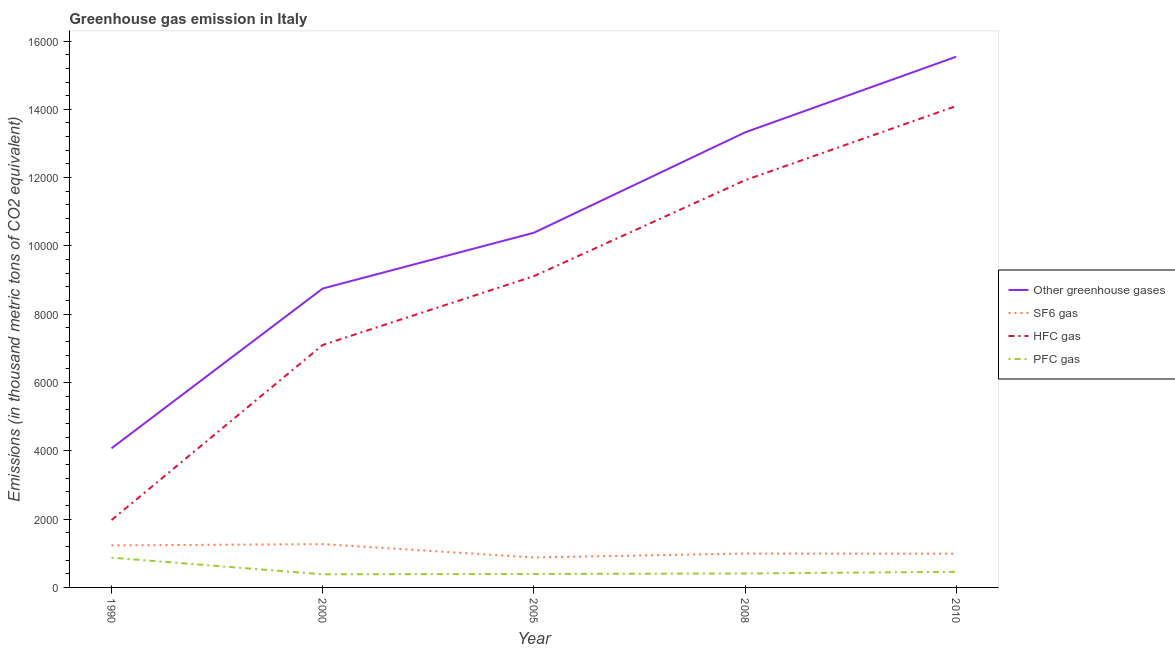How many different coloured lines are there?
Keep it short and to the point. 4. Does the line corresponding to emission of sf6 gas intersect with the line corresponding to emission of pfc gas?
Provide a succinct answer. No. Is the number of lines equal to the number of legend labels?
Keep it short and to the point. Yes. What is the emission of hfc gas in 2000?
Make the answer very short. 7099.5. Across all years, what is the maximum emission of hfc gas?
Your answer should be very brief. 1.41e+04. Across all years, what is the minimum emission of hfc gas?
Your answer should be very brief. 1972.2. In which year was the emission of hfc gas maximum?
Your response must be concise. 2010. In which year was the emission of pfc gas minimum?
Keep it short and to the point. 2000. What is the total emission of pfc gas in the graph?
Offer a very short reply. 2515.4. What is the difference between the emission of hfc gas in 2000 and that in 2005?
Your answer should be very brief. -2015. What is the difference between the emission of hfc gas in 2000 and the emission of sf6 gas in 2008?
Provide a succinct answer. 6107.4. What is the average emission of sf6 gas per year?
Your answer should be very brief. 1071.12. In the year 2008, what is the difference between the emission of pfc gas and emission of hfc gas?
Make the answer very short. -1.15e+04. What is the ratio of the emission of sf6 gas in 2000 to that in 2010?
Ensure brevity in your answer.  1.29. Is the emission of greenhouse gases in 1990 less than that in 2008?
Provide a succinct answer. Yes. Is the difference between the emission of greenhouse gases in 2000 and 2010 greater than the difference between the emission of pfc gas in 2000 and 2010?
Provide a short and direct response. No. What is the difference between the highest and the second highest emission of pfc gas?
Offer a very short reply. 414. What is the difference between the highest and the lowest emission of greenhouse gases?
Your response must be concise. 1.15e+04. In how many years, is the emission of sf6 gas greater than the average emission of sf6 gas taken over all years?
Ensure brevity in your answer.  2. Is the sum of the emission of hfc gas in 1990 and 2000 greater than the maximum emission of sf6 gas across all years?
Your answer should be very brief. Yes. Does the emission of hfc gas monotonically increase over the years?
Offer a terse response. Yes. Is the emission of sf6 gas strictly greater than the emission of pfc gas over the years?
Your answer should be very brief. Yes. Is the emission of greenhouse gases strictly less than the emission of hfc gas over the years?
Keep it short and to the point. No. What is the difference between two consecutive major ticks on the Y-axis?
Keep it short and to the point. 2000. Are the values on the major ticks of Y-axis written in scientific E-notation?
Keep it short and to the point. No. Does the graph contain any zero values?
Provide a short and direct response. No. What is the title of the graph?
Provide a succinct answer. Greenhouse gas emission in Italy. What is the label or title of the X-axis?
Ensure brevity in your answer.  Year. What is the label or title of the Y-axis?
Offer a very short reply. Emissions (in thousand metric tons of CO2 equivalent). What is the Emissions (in thousand metric tons of CO2 equivalent) in Other greenhouse gases in 1990?
Provide a short and direct response. 4074. What is the Emissions (in thousand metric tons of CO2 equivalent) in SF6 gas in 1990?
Keep it short and to the point. 1230.8. What is the Emissions (in thousand metric tons of CO2 equivalent) in HFC gas in 1990?
Keep it short and to the point. 1972.2. What is the Emissions (in thousand metric tons of CO2 equivalent) of PFC gas in 1990?
Offer a terse response. 871. What is the Emissions (in thousand metric tons of CO2 equivalent) in Other greenhouse gases in 2000?
Make the answer very short. 8752.3. What is the Emissions (in thousand metric tons of CO2 equivalent) of SF6 gas in 2000?
Your answer should be compact. 1268.5. What is the Emissions (in thousand metric tons of CO2 equivalent) of HFC gas in 2000?
Ensure brevity in your answer.  7099.5. What is the Emissions (in thousand metric tons of CO2 equivalent) in PFC gas in 2000?
Provide a succinct answer. 384.3. What is the Emissions (in thousand metric tons of CO2 equivalent) of Other greenhouse gases in 2005?
Give a very brief answer. 1.04e+04. What is the Emissions (in thousand metric tons of CO2 equivalent) in SF6 gas in 2005?
Your response must be concise. 877.2. What is the Emissions (in thousand metric tons of CO2 equivalent) of HFC gas in 2005?
Ensure brevity in your answer.  9114.5. What is the Emissions (in thousand metric tons of CO2 equivalent) in PFC gas in 2005?
Your answer should be compact. 394.3. What is the Emissions (in thousand metric tons of CO2 equivalent) in Other greenhouse gases in 2008?
Offer a very short reply. 1.33e+04. What is the Emissions (in thousand metric tons of CO2 equivalent) of SF6 gas in 2008?
Your response must be concise. 992.1. What is the Emissions (in thousand metric tons of CO2 equivalent) of HFC gas in 2008?
Your answer should be very brief. 1.19e+04. What is the Emissions (in thousand metric tons of CO2 equivalent) in PFC gas in 2008?
Give a very brief answer. 408.8. What is the Emissions (in thousand metric tons of CO2 equivalent) of Other greenhouse gases in 2010?
Your response must be concise. 1.55e+04. What is the Emissions (in thousand metric tons of CO2 equivalent) of SF6 gas in 2010?
Your answer should be compact. 987. What is the Emissions (in thousand metric tons of CO2 equivalent) in HFC gas in 2010?
Your answer should be very brief. 1.41e+04. What is the Emissions (in thousand metric tons of CO2 equivalent) of PFC gas in 2010?
Offer a terse response. 457. Across all years, what is the maximum Emissions (in thousand metric tons of CO2 equivalent) in Other greenhouse gases?
Offer a terse response. 1.55e+04. Across all years, what is the maximum Emissions (in thousand metric tons of CO2 equivalent) in SF6 gas?
Your response must be concise. 1268.5. Across all years, what is the maximum Emissions (in thousand metric tons of CO2 equivalent) in HFC gas?
Offer a terse response. 1.41e+04. Across all years, what is the maximum Emissions (in thousand metric tons of CO2 equivalent) of PFC gas?
Your answer should be compact. 871. Across all years, what is the minimum Emissions (in thousand metric tons of CO2 equivalent) in Other greenhouse gases?
Provide a succinct answer. 4074. Across all years, what is the minimum Emissions (in thousand metric tons of CO2 equivalent) in SF6 gas?
Give a very brief answer. 877.2. Across all years, what is the minimum Emissions (in thousand metric tons of CO2 equivalent) in HFC gas?
Your answer should be very brief. 1972.2. Across all years, what is the minimum Emissions (in thousand metric tons of CO2 equivalent) of PFC gas?
Provide a short and direct response. 384.3. What is the total Emissions (in thousand metric tons of CO2 equivalent) in Other greenhouse gases in the graph?
Offer a terse response. 5.21e+04. What is the total Emissions (in thousand metric tons of CO2 equivalent) in SF6 gas in the graph?
Your answer should be compact. 5355.6. What is the total Emissions (in thousand metric tons of CO2 equivalent) of HFC gas in the graph?
Ensure brevity in your answer.  4.42e+04. What is the total Emissions (in thousand metric tons of CO2 equivalent) in PFC gas in the graph?
Your response must be concise. 2515.4. What is the difference between the Emissions (in thousand metric tons of CO2 equivalent) of Other greenhouse gases in 1990 and that in 2000?
Your response must be concise. -4678.3. What is the difference between the Emissions (in thousand metric tons of CO2 equivalent) in SF6 gas in 1990 and that in 2000?
Provide a short and direct response. -37.7. What is the difference between the Emissions (in thousand metric tons of CO2 equivalent) in HFC gas in 1990 and that in 2000?
Ensure brevity in your answer.  -5127.3. What is the difference between the Emissions (in thousand metric tons of CO2 equivalent) of PFC gas in 1990 and that in 2000?
Provide a short and direct response. 486.7. What is the difference between the Emissions (in thousand metric tons of CO2 equivalent) of Other greenhouse gases in 1990 and that in 2005?
Provide a short and direct response. -6312. What is the difference between the Emissions (in thousand metric tons of CO2 equivalent) in SF6 gas in 1990 and that in 2005?
Your answer should be compact. 353.6. What is the difference between the Emissions (in thousand metric tons of CO2 equivalent) of HFC gas in 1990 and that in 2005?
Keep it short and to the point. -7142.3. What is the difference between the Emissions (in thousand metric tons of CO2 equivalent) of PFC gas in 1990 and that in 2005?
Make the answer very short. 476.7. What is the difference between the Emissions (in thousand metric tons of CO2 equivalent) in Other greenhouse gases in 1990 and that in 2008?
Your answer should be compact. -9251.4. What is the difference between the Emissions (in thousand metric tons of CO2 equivalent) in SF6 gas in 1990 and that in 2008?
Keep it short and to the point. 238.7. What is the difference between the Emissions (in thousand metric tons of CO2 equivalent) of HFC gas in 1990 and that in 2008?
Your answer should be compact. -9952.3. What is the difference between the Emissions (in thousand metric tons of CO2 equivalent) in PFC gas in 1990 and that in 2008?
Your answer should be very brief. 462.2. What is the difference between the Emissions (in thousand metric tons of CO2 equivalent) in Other greenhouse gases in 1990 and that in 2010?
Give a very brief answer. -1.15e+04. What is the difference between the Emissions (in thousand metric tons of CO2 equivalent) in SF6 gas in 1990 and that in 2010?
Your answer should be very brief. 243.8. What is the difference between the Emissions (in thousand metric tons of CO2 equivalent) of HFC gas in 1990 and that in 2010?
Keep it short and to the point. -1.21e+04. What is the difference between the Emissions (in thousand metric tons of CO2 equivalent) in PFC gas in 1990 and that in 2010?
Ensure brevity in your answer.  414. What is the difference between the Emissions (in thousand metric tons of CO2 equivalent) of Other greenhouse gases in 2000 and that in 2005?
Keep it short and to the point. -1633.7. What is the difference between the Emissions (in thousand metric tons of CO2 equivalent) in SF6 gas in 2000 and that in 2005?
Your answer should be compact. 391.3. What is the difference between the Emissions (in thousand metric tons of CO2 equivalent) in HFC gas in 2000 and that in 2005?
Provide a short and direct response. -2015. What is the difference between the Emissions (in thousand metric tons of CO2 equivalent) in Other greenhouse gases in 2000 and that in 2008?
Your answer should be compact. -4573.1. What is the difference between the Emissions (in thousand metric tons of CO2 equivalent) of SF6 gas in 2000 and that in 2008?
Provide a short and direct response. 276.4. What is the difference between the Emissions (in thousand metric tons of CO2 equivalent) of HFC gas in 2000 and that in 2008?
Offer a very short reply. -4825. What is the difference between the Emissions (in thousand metric tons of CO2 equivalent) of PFC gas in 2000 and that in 2008?
Ensure brevity in your answer.  -24.5. What is the difference between the Emissions (in thousand metric tons of CO2 equivalent) of Other greenhouse gases in 2000 and that in 2010?
Offer a terse response. -6788.7. What is the difference between the Emissions (in thousand metric tons of CO2 equivalent) of SF6 gas in 2000 and that in 2010?
Your response must be concise. 281.5. What is the difference between the Emissions (in thousand metric tons of CO2 equivalent) of HFC gas in 2000 and that in 2010?
Provide a short and direct response. -6997.5. What is the difference between the Emissions (in thousand metric tons of CO2 equivalent) in PFC gas in 2000 and that in 2010?
Provide a short and direct response. -72.7. What is the difference between the Emissions (in thousand metric tons of CO2 equivalent) in Other greenhouse gases in 2005 and that in 2008?
Offer a terse response. -2939.4. What is the difference between the Emissions (in thousand metric tons of CO2 equivalent) of SF6 gas in 2005 and that in 2008?
Your response must be concise. -114.9. What is the difference between the Emissions (in thousand metric tons of CO2 equivalent) in HFC gas in 2005 and that in 2008?
Keep it short and to the point. -2810. What is the difference between the Emissions (in thousand metric tons of CO2 equivalent) in Other greenhouse gases in 2005 and that in 2010?
Keep it short and to the point. -5155. What is the difference between the Emissions (in thousand metric tons of CO2 equivalent) in SF6 gas in 2005 and that in 2010?
Give a very brief answer. -109.8. What is the difference between the Emissions (in thousand metric tons of CO2 equivalent) in HFC gas in 2005 and that in 2010?
Your answer should be compact. -4982.5. What is the difference between the Emissions (in thousand metric tons of CO2 equivalent) of PFC gas in 2005 and that in 2010?
Ensure brevity in your answer.  -62.7. What is the difference between the Emissions (in thousand metric tons of CO2 equivalent) of Other greenhouse gases in 2008 and that in 2010?
Make the answer very short. -2215.6. What is the difference between the Emissions (in thousand metric tons of CO2 equivalent) in HFC gas in 2008 and that in 2010?
Provide a short and direct response. -2172.5. What is the difference between the Emissions (in thousand metric tons of CO2 equivalent) of PFC gas in 2008 and that in 2010?
Your answer should be compact. -48.2. What is the difference between the Emissions (in thousand metric tons of CO2 equivalent) in Other greenhouse gases in 1990 and the Emissions (in thousand metric tons of CO2 equivalent) in SF6 gas in 2000?
Offer a very short reply. 2805.5. What is the difference between the Emissions (in thousand metric tons of CO2 equivalent) of Other greenhouse gases in 1990 and the Emissions (in thousand metric tons of CO2 equivalent) of HFC gas in 2000?
Keep it short and to the point. -3025.5. What is the difference between the Emissions (in thousand metric tons of CO2 equivalent) in Other greenhouse gases in 1990 and the Emissions (in thousand metric tons of CO2 equivalent) in PFC gas in 2000?
Offer a very short reply. 3689.7. What is the difference between the Emissions (in thousand metric tons of CO2 equivalent) of SF6 gas in 1990 and the Emissions (in thousand metric tons of CO2 equivalent) of HFC gas in 2000?
Make the answer very short. -5868.7. What is the difference between the Emissions (in thousand metric tons of CO2 equivalent) in SF6 gas in 1990 and the Emissions (in thousand metric tons of CO2 equivalent) in PFC gas in 2000?
Your answer should be compact. 846.5. What is the difference between the Emissions (in thousand metric tons of CO2 equivalent) in HFC gas in 1990 and the Emissions (in thousand metric tons of CO2 equivalent) in PFC gas in 2000?
Offer a terse response. 1587.9. What is the difference between the Emissions (in thousand metric tons of CO2 equivalent) in Other greenhouse gases in 1990 and the Emissions (in thousand metric tons of CO2 equivalent) in SF6 gas in 2005?
Give a very brief answer. 3196.8. What is the difference between the Emissions (in thousand metric tons of CO2 equivalent) in Other greenhouse gases in 1990 and the Emissions (in thousand metric tons of CO2 equivalent) in HFC gas in 2005?
Make the answer very short. -5040.5. What is the difference between the Emissions (in thousand metric tons of CO2 equivalent) of Other greenhouse gases in 1990 and the Emissions (in thousand metric tons of CO2 equivalent) of PFC gas in 2005?
Your answer should be compact. 3679.7. What is the difference between the Emissions (in thousand metric tons of CO2 equivalent) in SF6 gas in 1990 and the Emissions (in thousand metric tons of CO2 equivalent) in HFC gas in 2005?
Ensure brevity in your answer.  -7883.7. What is the difference between the Emissions (in thousand metric tons of CO2 equivalent) of SF6 gas in 1990 and the Emissions (in thousand metric tons of CO2 equivalent) of PFC gas in 2005?
Make the answer very short. 836.5. What is the difference between the Emissions (in thousand metric tons of CO2 equivalent) of HFC gas in 1990 and the Emissions (in thousand metric tons of CO2 equivalent) of PFC gas in 2005?
Your answer should be very brief. 1577.9. What is the difference between the Emissions (in thousand metric tons of CO2 equivalent) in Other greenhouse gases in 1990 and the Emissions (in thousand metric tons of CO2 equivalent) in SF6 gas in 2008?
Give a very brief answer. 3081.9. What is the difference between the Emissions (in thousand metric tons of CO2 equivalent) of Other greenhouse gases in 1990 and the Emissions (in thousand metric tons of CO2 equivalent) of HFC gas in 2008?
Keep it short and to the point. -7850.5. What is the difference between the Emissions (in thousand metric tons of CO2 equivalent) in Other greenhouse gases in 1990 and the Emissions (in thousand metric tons of CO2 equivalent) in PFC gas in 2008?
Your answer should be compact. 3665.2. What is the difference between the Emissions (in thousand metric tons of CO2 equivalent) of SF6 gas in 1990 and the Emissions (in thousand metric tons of CO2 equivalent) of HFC gas in 2008?
Your response must be concise. -1.07e+04. What is the difference between the Emissions (in thousand metric tons of CO2 equivalent) of SF6 gas in 1990 and the Emissions (in thousand metric tons of CO2 equivalent) of PFC gas in 2008?
Your answer should be very brief. 822. What is the difference between the Emissions (in thousand metric tons of CO2 equivalent) in HFC gas in 1990 and the Emissions (in thousand metric tons of CO2 equivalent) in PFC gas in 2008?
Provide a short and direct response. 1563.4. What is the difference between the Emissions (in thousand metric tons of CO2 equivalent) in Other greenhouse gases in 1990 and the Emissions (in thousand metric tons of CO2 equivalent) in SF6 gas in 2010?
Provide a short and direct response. 3087. What is the difference between the Emissions (in thousand metric tons of CO2 equivalent) in Other greenhouse gases in 1990 and the Emissions (in thousand metric tons of CO2 equivalent) in HFC gas in 2010?
Give a very brief answer. -1.00e+04. What is the difference between the Emissions (in thousand metric tons of CO2 equivalent) of Other greenhouse gases in 1990 and the Emissions (in thousand metric tons of CO2 equivalent) of PFC gas in 2010?
Your answer should be very brief. 3617. What is the difference between the Emissions (in thousand metric tons of CO2 equivalent) in SF6 gas in 1990 and the Emissions (in thousand metric tons of CO2 equivalent) in HFC gas in 2010?
Ensure brevity in your answer.  -1.29e+04. What is the difference between the Emissions (in thousand metric tons of CO2 equivalent) of SF6 gas in 1990 and the Emissions (in thousand metric tons of CO2 equivalent) of PFC gas in 2010?
Provide a short and direct response. 773.8. What is the difference between the Emissions (in thousand metric tons of CO2 equivalent) in HFC gas in 1990 and the Emissions (in thousand metric tons of CO2 equivalent) in PFC gas in 2010?
Keep it short and to the point. 1515.2. What is the difference between the Emissions (in thousand metric tons of CO2 equivalent) in Other greenhouse gases in 2000 and the Emissions (in thousand metric tons of CO2 equivalent) in SF6 gas in 2005?
Provide a short and direct response. 7875.1. What is the difference between the Emissions (in thousand metric tons of CO2 equivalent) of Other greenhouse gases in 2000 and the Emissions (in thousand metric tons of CO2 equivalent) of HFC gas in 2005?
Your response must be concise. -362.2. What is the difference between the Emissions (in thousand metric tons of CO2 equivalent) in Other greenhouse gases in 2000 and the Emissions (in thousand metric tons of CO2 equivalent) in PFC gas in 2005?
Keep it short and to the point. 8358. What is the difference between the Emissions (in thousand metric tons of CO2 equivalent) of SF6 gas in 2000 and the Emissions (in thousand metric tons of CO2 equivalent) of HFC gas in 2005?
Provide a short and direct response. -7846. What is the difference between the Emissions (in thousand metric tons of CO2 equivalent) of SF6 gas in 2000 and the Emissions (in thousand metric tons of CO2 equivalent) of PFC gas in 2005?
Your answer should be very brief. 874.2. What is the difference between the Emissions (in thousand metric tons of CO2 equivalent) in HFC gas in 2000 and the Emissions (in thousand metric tons of CO2 equivalent) in PFC gas in 2005?
Provide a short and direct response. 6705.2. What is the difference between the Emissions (in thousand metric tons of CO2 equivalent) in Other greenhouse gases in 2000 and the Emissions (in thousand metric tons of CO2 equivalent) in SF6 gas in 2008?
Your answer should be compact. 7760.2. What is the difference between the Emissions (in thousand metric tons of CO2 equivalent) in Other greenhouse gases in 2000 and the Emissions (in thousand metric tons of CO2 equivalent) in HFC gas in 2008?
Your answer should be very brief. -3172.2. What is the difference between the Emissions (in thousand metric tons of CO2 equivalent) of Other greenhouse gases in 2000 and the Emissions (in thousand metric tons of CO2 equivalent) of PFC gas in 2008?
Provide a succinct answer. 8343.5. What is the difference between the Emissions (in thousand metric tons of CO2 equivalent) in SF6 gas in 2000 and the Emissions (in thousand metric tons of CO2 equivalent) in HFC gas in 2008?
Make the answer very short. -1.07e+04. What is the difference between the Emissions (in thousand metric tons of CO2 equivalent) in SF6 gas in 2000 and the Emissions (in thousand metric tons of CO2 equivalent) in PFC gas in 2008?
Ensure brevity in your answer.  859.7. What is the difference between the Emissions (in thousand metric tons of CO2 equivalent) in HFC gas in 2000 and the Emissions (in thousand metric tons of CO2 equivalent) in PFC gas in 2008?
Your response must be concise. 6690.7. What is the difference between the Emissions (in thousand metric tons of CO2 equivalent) of Other greenhouse gases in 2000 and the Emissions (in thousand metric tons of CO2 equivalent) of SF6 gas in 2010?
Your answer should be very brief. 7765.3. What is the difference between the Emissions (in thousand metric tons of CO2 equivalent) of Other greenhouse gases in 2000 and the Emissions (in thousand metric tons of CO2 equivalent) of HFC gas in 2010?
Your answer should be compact. -5344.7. What is the difference between the Emissions (in thousand metric tons of CO2 equivalent) in Other greenhouse gases in 2000 and the Emissions (in thousand metric tons of CO2 equivalent) in PFC gas in 2010?
Your answer should be very brief. 8295.3. What is the difference between the Emissions (in thousand metric tons of CO2 equivalent) of SF6 gas in 2000 and the Emissions (in thousand metric tons of CO2 equivalent) of HFC gas in 2010?
Offer a very short reply. -1.28e+04. What is the difference between the Emissions (in thousand metric tons of CO2 equivalent) of SF6 gas in 2000 and the Emissions (in thousand metric tons of CO2 equivalent) of PFC gas in 2010?
Make the answer very short. 811.5. What is the difference between the Emissions (in thousand metric tons of CO2 equivalent) of HFC gas in 2000 and the Emissions (in thousand metric tons of CO2 equivalent) of PFC gas in 2010?
Your response must be concise. 6642.5. What is the difference between the Emissions (in thousand metric tons of CO2 equivalent) in Other greenhouse gases in 2005 and the Emissions (in thousand metric tons of CO2 equivalent) in SF6 gas in 2008?
Keep it short and to the point. 9393.9. What is the difference between the Emissions (in thousand metric tons of CO2 equivalent) of Other greenhouse gases in 2005 and the Emissions (in thousand metric tons of CO2 equivalent) of HFC gas in 2008?
Provide a succinct answer. -1538.5. What is the difference between the Emissions (in thousand metric tons of CO2 equivalent) in Other greenhouse gases in 2005 and the Emissions (in thousand metric tons of CO2 equivalent) in PFC gas in 2008?
Offer a terse response. 9977.2. What is the difference between the Emissions (in thousand metric tons of CO2 equivalent) of SF6 gas in 2005 and the Emissions (in thousand metric tons of CO2 equivalent) of HFC gas in 2008?
Provide a succinct answer. -1.10e+04. What is the difference between the Emissions (in thousand metric tons of CO2 equivalent) in SF6 gas in 2005 and the Emissions (in thousand metric tons of CO2 equivalent) in PFC gas in 2008?
Make the answer very short. 468.4. What is the difference between the Emissions (in thousand metric tons of CO2 equivalent) of HFC gas in 2005 and the Emissions (in thousand metric tons of CO2 equivalent) of PFC gas in 2008?
Provide a short and direct response. 8705.7. What is the difference between the Emissions (in thousand metric tons of CO2 equivalent) of Other greenhouse gases in 2005 and the Emissions (in thousand metric tons of CO2 equivalent) of SF6 gas in 2010?
Provide a succinct answer. 9399. What is the difference between the Emissions (in thousand metric tons of CO2 equivalent) in Other greenhouse gases in 2005 and the Emissions (in thousand metric tons of CO2 equivalent) in HFC gas in 2010?
Your response must be concise. -3711. What is the difference between the Emissions (in thousand metric tons of CO2 equivalent) in Other greenhouse gases in 2005 and the Emissions (in thousand metric tons of CO2 equivalent) in PFC gas in 2010?
Your answer should be very brief. 9929. What is the difference between the Emissions (in thousand metric tons of CO2 equivalent) in SF6 gas in 2005 and the Emissions (in thousand metric tons of CO2 equivalent) in HFC gas in 2010?
Give a very brief answer. -1.32e+04. What is the difference between the Emissions (in thousand metric tons of CO2 equivalent) of SF6 gas in 2005 and the Emissions (in thousand metric tons of CO2 equivalent) of PFC gas in 2010?
Ensure brevity in your answer.  420.2. What is the difference between the Emissions (in thousand metric tons of CO2 equivalent) of HFC gas in 2005 and the Emissions (in thousand metric tons of CO2 equivalent) of PFC gas in 2010?
Provide a short and direct response. 8657.5. What is the difference between the Emissions (in thousand metric tons of CO2 equivalent) of Other greenhouse gases in 2008 and the Emissions (in thousand metric tons of CO2 equivalent) of SF6 gas in 2010?
Offer a very short reply. 1.23e+04. What is the difference between the Emissions (in thousand metric tons of CO2 equivalent) in Other greenhouse gases in 2008 and the Emissions (in thousand metric tons of CO2 equivalent) in HFC gas in 2010?
Give a very brief answer. -771.6. What is the difference between the Emissions (in thousand metric tons of CO2 equivalent) in Other greenhouse gases in 2008 and the Emissions (in thousand metric tons of CO2 equivalent) in PFC gas in 2010?
Give a very brief answer. 1.29e+04. What is the difference between the Emissions (in thousand metric tons of CO2 equivalent) of SF6 gas in 2008 and the Emissions (in thousand metric tons of CO2 equivalent) of HFC gas in 2010?
Your answer should be compact. -1.31e+04. What is the difference between the Emissions (in thousand metric tons of CO2 equivalent) of SF6 gas in 2008 and the Emissions (in thousand metric tons of CO2 equivalent) of PFC gas in 2010?
Your answer should be very brief. 535.1. What is the difference between the Emissions (in thousand metric tons of CO2 equivalent) in HFC gas in 2008 and the Emissions (in thousand metric tons of CO2 equivalent) in PFC gas in 2010?
Provide a short and direct response. 1.15e+04. What is the average Emissions (in thousand metric tons of CO2 equivalent) in Other greenhouse gases per year?
Give a very brief answer. 1.04e+04. What is the average Emissions (in thousand metric tons of CO2 equivalent) in SF6 gas per year?
Your response must be concise. 1071.12. What is the average Emissions (in thousand metric tons of CO2 equivalent) in HFC gas per year?
Offer a very short reply. 8841.54. What is the average Emissions (in thousand metric tons of CO2 equivalent) in PFC gas per year?
Provide a succinct answer. 503.08. In the year 1990, what is the difference between the Emissions (in thousand metric tons of CO2 equivalent) in Other greenhouse gases and Emissions (in thousand metric tons of CO2 equivalent) in SF6 gas?
Offer a very short reply. 2843.2. In the year 1990, what is the difference between the Emissions (in thousand metric tons of CO2 equivalent) in Other greenhouse gases and Emissions (in thousand metric tons of CO2 equivalent) in HFC gas?
Provide a short and direct response. 2101.8. In the year 1990, what is the difference between the Emissions (in thousand metric tons of CO2 equivalent) in Other greenhouse gases and Emissions (in thousand metric tons of CO2 equivalent) in PFC gas?
Your response must be concise. 3203. In the year 1990, what is the difference between the Emissions (in thousand metric tons of CO2 equivalent) of SF6 gas and Emissions (in thousand metric tons of CO2 equivalent) of HFC gas?
Provide a short and direct response. -741.4. In the year 1990, what is the difference between the Emissions (in thousand metric tons of CO2 equivalent) in SF6 gas and Emissions (in thousand metric tons of CO2 equivalent) in PFC gas?
Your response must be concise. 359.8. In the year 1990, what is the difference between the Emissions (in thousand metric tons of CO2 equivalent) of HFC gas and Emissions (in thousand metric tons of CO2 equivalent) of PFC gas?
Make the answer very short. 1101.2. In the year 2000, what is the difference between the Emissions (in thousand metric tons of CO2 equivalent) in Other greenhouse gases and Emissions (in thousand metric tons of CO2 equivalent) in SF6 gas?
Ensure brevity in your answer.  7483.8. In the year 2000, what is the difference between the Emissions (in thousand metric tons of CO2 equivalent) in Other greenhouse gases and Emissions (in thousand metric tons of CO2 equivalent) in HFC gas?
Your answer should be compact. 1652.8. In the year 2000, what is the difference between the Emissions (in thousand metric tons of CO2 equivalent) of Other greenhouse gases and Emissions (in thousand metric tons of CO2 equivalent) of PFC gas?
Offer a very short reply. 8368. In the year 2000, what is the difference between the Emissions (in thousand metric tons of CO2 equivalent) of SF6 gas and Emissions (in thousand metric tons of CO2 equivalent) of HFC gas?
Offer a terse response. -5831. In the year 2000, what is the difference between the Emissions (in thousand metric tons of CO2 equivalent) of SF6 gas and Emissions (in thousand metric tons of CO2 equivalent) of PFC gas?
Your response must be concise. 884.2. In the year 2000, what is the difference between the Emissions (in thousand metric tons of CO2 equivalent) in HFC gas and Emissions (in thousand metric tons of CO2 equivalent) in PFC gas?
Your answer should be very brief. 6715.2. In the year 2005, what is the difference between the Emissions (in thousand metric tons of CO2 equivalent) of Other greenhouse gases and Emissions (in thousand metric tons of CO2 equivalent) of SF6 gas?
Your answer should be compact. 9508.8. In the year 2005, what is the difference between the Emissions (in thousand metric tons of CO2 equivalent) in Other greenhouse gases and Emissions (in thousand metric tons of CO2 equivalent) in HFC gas?
Make the answer very short. 1271.5. In the year 2005, what is the difference between the Emissions (in thousand metric tons of CO2 equivalent) of Other greenhouse gases and Emissions (in thousand metric tons of CO2 equivalent) of PFC gas?
Ensure brevity in your answer.  9991.7. In the year 2005, what is the difference between the Emissions (in thousand metric tons of CO2 equivalent) in SF6 gas and Emissions (in thousand metric tons of CO2 equivalent) in HFC gas?
Ensure brevity in your answer.  -8237.3. In the year 2005, what is the difference between the Emissions (in thousand metric tons of CO2 equivalent) of SF6 gas and Emissions (in thousand metric tons of CO2 equivalent) of PFC gas?
Give a very brief answer. 482.9. In the year 2005, what is the difference between the Emissions (in thousand metric tons of CO2 equivalent) in HFC gas and Emissions (in thousand metric tons of CO2 equivalent) in PFC gas?
Provide a short and direct response. 8720.2. In the year 2008, what is the difference between the Emissions (in thousand metric tons of CO2 equivalent) in Other greenhouse gases and Emissions (in thousand metric tons of CO2 equivalent) in SF6 gas?
Keep it short and to the point. 1.23e+04. In the year 2008, what is the difference between the Emissions (in thousand metric tons of CO2 equivalent) of Other greenhouse gases and Emissions (in thousand metric tons of CO2 equivalent) of HFC gas?
Your answer should be very brief. 1400.9. In the year 2008, what is the difference between the Emissions (in thousand metric tons of CO2 equivalent) of Other greenhouse gases and Emissions (in thousand metric tons of CO2 equivalent) of PFC gas?
Ensure brevity in your answer.  1.29e+04. In the year 2008, what is the difference between the Emissions (in thousand metric tons of CO2 equivalent) in SF6 gas and Emissions (in thousand metric tons of CO2 equivalent) in HFC gas?
Give a very brief answer. -1.09e+04. In the year 2008, what is the difference between the Emissions (in thousand metric tons of CO2 equivalent) in SF6 gas and Emissions (in thousand metric tons of CO2 equivalent) in PFC gas?
Offer a terse response. 583.3. In the year 2008, what is the difference between the Emissions (in thousand metric tons of CO2 equivalent) in HFC gas and Emissions (in thousand metric tons of CO2 equivalent) in PFC gas?
Offer a terse response. 1.15e+04. In the year 2010, what is the difference between the Emissions (in thousand metric tons of CO2 equivalent) of Other greenhouse gases and Emissions (in thousand metric tons of CO2 equivalent) of SF6 gas?
Provide a succinct answer. 1.46e+04. In the year 2010, what is the difference between the Emissions (in thousand metric tons of CO2 equivalent) of Other greenhouse gases and Emissions (in thousand metric tons of CO2 equivalent) of HFC gas?
Make the answer very short. 1444. In the year 2010, what is the difference between the Emissions (in thousand metric tons of CO2 equivalent) of Other greenhouse gases and Emissions (in thousand metric tons of CO2 equivalent) of PFC gas?
Your answer should be very brief. 1.51e+04. In the year 2010, what is the difference between the Emissions (in thousand metric tons of CO2 equivalent) of SF6 gas and Emissions (in thousand metric tons of CO2 equivalent) of HFC gas?
Provide a short and direct response. -1.31e+04. In the year 2010, what is the difference between the Emissions (in thousand metric tons of CO2 equivalent) of SF6 gas and Emissions (in thousand metric tons of CO2 equivalent) of PFC gas?
Your response must be concise. 530. In the year 2010, what is the difference between the Emissions (in thousand metric tons of CO2 equivalent) in HFC gas and Emissions (in thousand metric tons of CO2 equivalent) in PFC gas?
Provide a succinct answer. 1.36e+04. What is the ratio of the Emissions (in thousand metric tons of CO2 equivalent) in Other greenhouse gases in 1990 to that in 2000?
Provide a succinct answer. 0.47. What is the ratio of the Emissions (in thousand metric tons of CO2 equivalent) of SF6 gas in 1990 to that in 2000?
Provide a succinct answer. 0.97. What is the ratio of the Emissions (in thousand metric tons of CO2 equivalent) in HFC gas in 1990 to that in 2000?
Make the answer very short. 0.28. What is the ratio of the Emissions (in thousand metric tons of CO2 equivalent) of PFC gas in 1990 to that in 2000?
Your answer should be very brief. 2.27. What is the ratio of the Emissions (in thousand metric tons of CO2 equivalent) in Other greenhouse gases in 1990 to that in 2005?
Ensure brevity in your answer.  0.39. What is the ratio of the Emissions (in thousand metric tons of CO2 equivalent) of SF6 gas in 1990 to that in 2005?
Ensure brevity in your answer.  1.4. What is the ratio of the Emissions (in thousand metric tons of CO2 equivalent) of HFC gas in 1990 to that in 2005?
Offer a very short reply. 0.22. What is the ratio of the Emissions (in thousand metric tons of CO2 equivalent) of PFC gas in 1990 to that in 2005?
Make the answer very short. 2.21. What is the ratio of the Emissions (in thousand metric tons of CO2 equivalent) of Other greenhouse gases in 1990 to that in 2008?
Your response must be concise. 0.31. What is the ratio of the Emissions (in thousand metric tons of CO2 equivalent) in SF6 gas in 1990 to that in 2008?
Ensure brevity in your answer.  1.24. What is the ratio of the Emissions (in thousand metric tons of CO2 equivalent) in HFC gas in 1990 to that in 2008?
Provide a short and direct response. 0.17. What is the ratio of the Emissions (in thousand metric tons of CO2 equivalent) of PFC gas in 1990 to that in 2008?
Ensure brevity in your answer.  2.13. What is the ratio of the Emissions (in thousand metric tons of CO2 equivalent) of Other greenhouse gases in 1990 to that in 2010?
Your response must be concise. 0.26. What is the ratio of the Emissions (in thousand metric tons of CO2 equivalent) of SF6 gas in 1990 to that in 2010?
Give a very brief answer. 1.25. What is the ratio of the Emissions (in thousand metric tons of CO2 equivalent) in HFC gas in 1990 to that in 2010?
Ensure brevity in your answer.  0.14. What is the ratio of the Emissions (in thousand metric tons of CO2 equivalent) in PFC gas in 1990 to that in 2010?
Give a very brief answer. 1.91. What is the ratio of the Emissions (in thousand metric tons of CO2 equivalent) of Other greenhouse gases in 2000 to that in 2005?
Your answer should be very brief. 0.84. What is the ratio of the Emissions (in thousand metric tons of CO2 equivalent) of SF6 gas in 2000 to that in 2005?
Your answer should be very brief. 1.45. What is the ratio of the Emissions (in thousand metric tons of CO2 equivalent) in HFC gas in 2000 to that in 2005?
Make the answer very short. 0.78. What is the ratio of the Emissions (in thousand metric tons of CO2 equivalent) in PFC gas in 2000 to that in 2005?
Give a very brief answer. 0.97. What is the ratio of the Emissions (in thousand metric tons of CO2 equivalent) of Other greenhouse gases in 2000 to that in 2008?
Offer a terse response. 0.66. What is the ratio of the Emissions (in thousand metric tons of CO2 equivalent) in SF6 gas in 2000 to that in 2008?
Ensure brevity in your answer.  1.28. What is the ratio of the Emissions (in thousand metric tons of CO2 equivalent) of HFC gas in 2000 to that in 2008?
Your response must be concise. 0.6. What is the ratio of the Emissions (in thousand metric tons of CO2 equivalent) in PFC gas in 2000 to that in 2008?
Your answer should be compact. 0.94. What is the ratio of the Emissions (in thousand metric tons of CO2 equivalent) of Other greenhouse gases in 2000 to that in 2010?
Give a very brief answer. 0.56. What is the ratio of the Emissions (in thousand metric tons of CO2 equivalent) of SF6 gas in 2000 to that in 2010?
Make the answer very short. 1.29. What is the ratio of the Emissions (in thousand metric tons of CO2 equivalent) of HFC gas in 2000 to that in 2010?
Offer a very short reply. 0.5. What is the ratio of the Emissions (in thousand metric tons of CO2 equivalent) in PFC gas in 2000 to that in 2010?
Your answer should be very brief. 0.84. What is the ratio of the Emissions (in thousand metric tons of CO2 equivalent) in Other greenhouse gases in 2005 to that in 2008?
Give a very brief answer. 0.78. What is the ratio of the Emissions (in thousand metric tons of CO2 equivalent) in SF6 gas in 2005 to that in 2008?
Give a very brief answer. 0.88. What is the ratio of the Emissions (in thousand metric tons of CO2 equivalent) of HFC gas in 2005 to that in 2008?
Your response must be concise. 0.76. What is the ratio of the Emissions (in thousand metric tons of CO2 equivalent) in PFC gas in 2005 to that in 2008?
Keep it short and to the point. 0.96. What is the ratio of the Emissions (in thousand metric tons of CO2 equivalent) in Other greenhouse gases in 2005 to that in 2010?
Provide a short and direct response. 0.67. What is the ratio of the Emissions (in thousand metric tons of CO2 equivalent) of SF6 gas in 2005 to that in 2010?
Your answer should be very brief. 0.89. What is the ratio of the Emissions (in thousand metric tons of CO2 equivalent) of HFC gas in 2005 to that in 2010?
Provide a succinct answer. 0.65. What is the ratio of the Emissions (in thousand metric tons of CO2 equivalent) in PFC gas in 2005 to that in 2010?
Provide a short and direct response. 0.86. What is the ratio of the Emissions (in thousand metric tons of CO2 equivalent) in Other greenhouse gases in 2008 to that in 2010?
Your response must be concise. 0.86. What is the ratio of the Emissions (in thousand metric tons of CO2 equivalent) of HFC gas in 2008 to that in 2010?
Provide a succinct answer. 0.85. What is the ratio of the Emissions (in thousand metric tons of CO2 equivalent) of PFC gas in 2008 to that in 2010?
Your response must be concise. 0.89. What is the difference between the highest and the second highest Emissions (in thousand metric tons of CO2 equivalent) in Other greenhouse gases?
Your response must be concise. 2215.6. What is the difference between the highest and the second highest Emissions (in thousand metric tons of CO2 equivalent) of SF6 gas?
Keep it short and to the point. 37.7. What is the difference between the highest and the second highest Emissions (in thousand metric tons of CO2 equivalent) of HFC gas?
Make the answer very short. 2172.5. What is the difference between the highest and the second highest Emissions (in thousand metric tons of CO2 equivalent) in PFC gas?
Provide a short and direct response. 414. What is the difference between the highest and the lowest Emissions (in thousand metric tons of CO2 equivalent) in Other greenhouse gases?
Give a very brief answer. 1.15e+04. What is the difference between the highest and the lowest Emissions (in thousand metric tons of CO2 equivalent) of SF6 gas?
Offer a very short reply. 391.3. What is the difference between the highest and the lowest Emissions (in thousand metric tons of CO2 equivalent) of HFC gas?
Make the answer very short. 1.21e+04. What is the difference between the highest and the lowest Emissions (in thousand metric tons of CO2 equivalent) of PFC gas?
Provide a short and direct response. 486.7. 